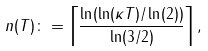Convert formula to latex. <formula><loc_0><loc_0><loc_500><loc_500>n ( T ) \colon = \left \lceil \frac { \ln ( \ln ( \kappa T ) / \ln ( 2 ) ) } { \ln ( 3 / 2 ) } \right \rceil ,</formula> 